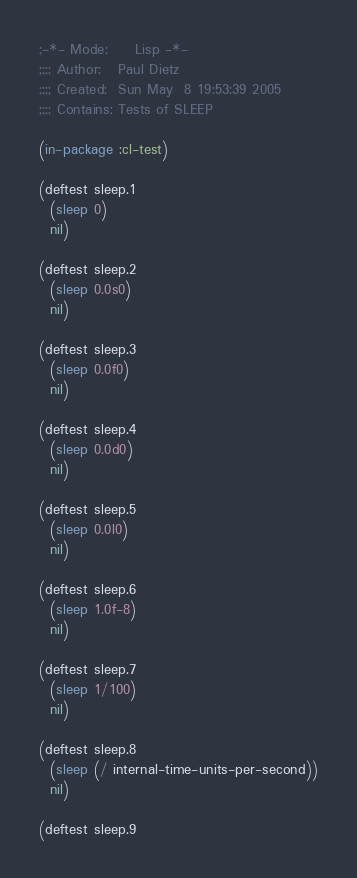<code> <loc_0><loc_0><loc_500><loc_500><_Lisp_>;-*- Mode:     Lisp -*-
;;;; Author:   Paul Dietz
;;;; Created:  Sun May  8 19:53:39 2005
;;;; Contains: Tests of SLEEP

(in-package :cl-test)

(deftest sleep.1
  (sleep 0)
  nil)

(deftest sleep.2
  (sleep 0.0s0)
  nil)

(deftest sleep.3
  (sleep 0.0f0)
  nil)

(deftest sleep.4
  (sleep 0.0d0)
  nil)

(deftest sleep.5
  (sleep 0.0l0)
  nil)

(deftest sleep.6
  (sleep 1.0f-8)
  nil)

(deftest sleep.7
  (sleep 1/100)
  nil)

(deftest sleep.8
  (sleep (/ internal-time-units-per-second))
  nil)

(deftest sleep.9</code> 